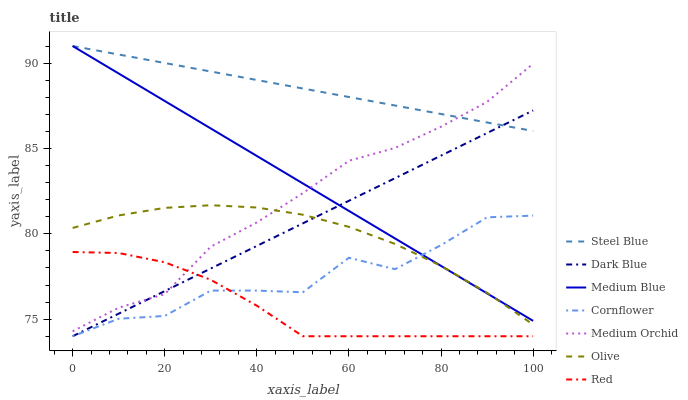Does Red have the minimum area under the curve?
Answer yes or no. Yes. Does Steel Blue have the maximum area under the curve?
Answer yes or no. Yes. Does Medium Orchid have the minimum area under the curve?
Answer yes or no. No. Does Medium Orchid have the maximum area under the curve?
Answer yes or no. No. Is Dark Blue the smoothest?
Answer yes or no. Yes. Is Cornflower the roughest?
Answer yes or no. Yes. Is Medium Orchid the smoothest?
Answer yes or no. No. Is Medium Orchid the roughest?
Answer yes or no. No. Does Cornflower have the lowest value?
Answer yes or no. Yes. Does Medium Orchid have the lowest value?
Answer yes or no. No. Does Steel Blue have the highest value?
Answer yes or no. Yes. Does Medium Orchid have the highest value?
Answer yes or no. No. Is Red less than Medium Blue?
Answer yes or no. Yes. Is Steel Blue greater than Olive?
Answer yes or no. Yes. Does Medium Blue intersect Medium Orchid?
Answer yes or no. Yes. Is Medium Blue less than Medium Orchid?
Answer yes or no. No. Is Medium Blue greater than Medium Orchid?
Answer yes or no. No. Does Red intersect Medium Blue?
Answer yes or no. No. 